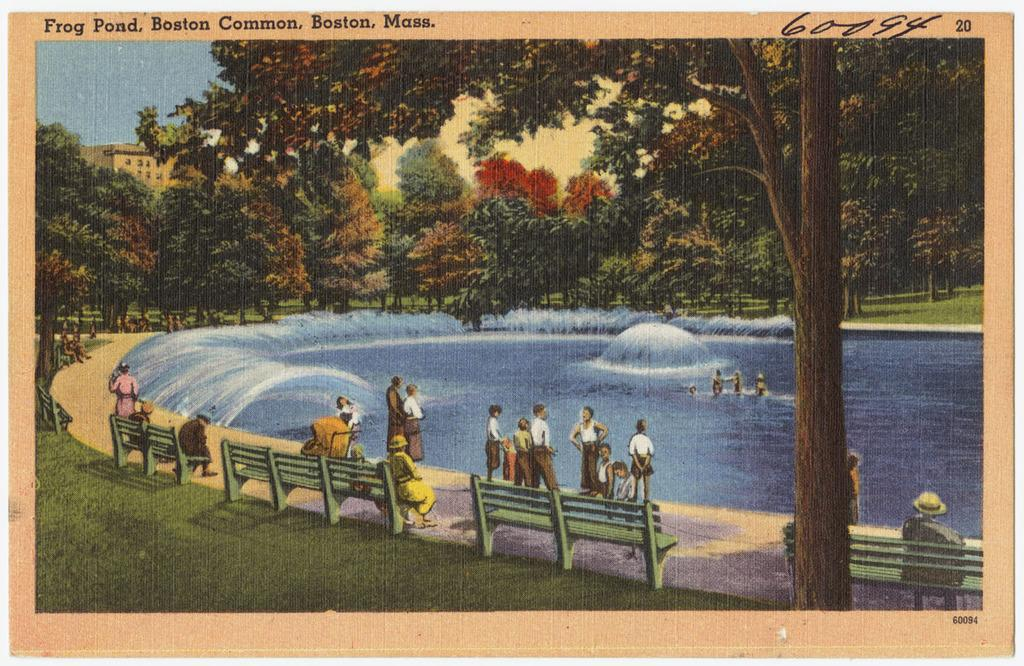<image>
Summarize the visual content of the image. A postcard shows a scene from Frog Pond in Boston, MA. 